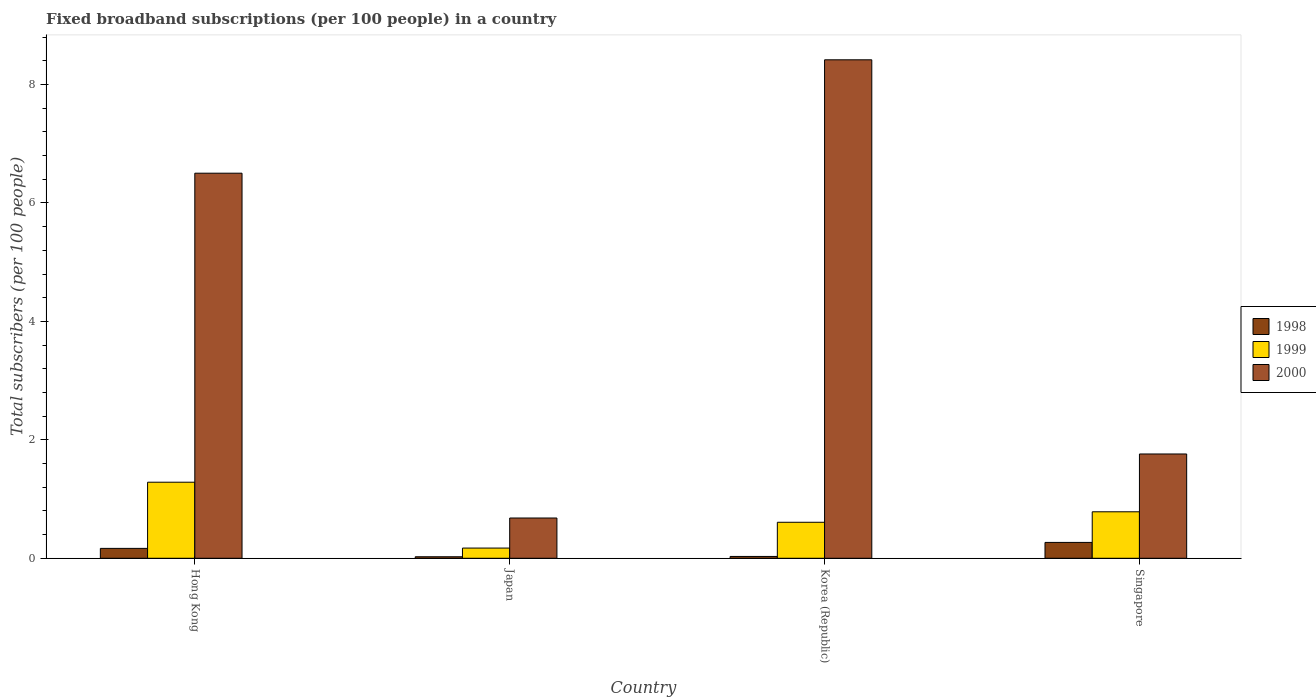How many different coloured bars are there?
Make the answer very short. 3. Are the number of bars on each tick of the X-axis equal?
Your answer should be very brief. Yes. How many bars are there on the 3rd tick from the left?
Your answer should be compact. 3. How many bars are there on the 2nd tick from the right?
Make the answer very short. 3. What is the label of the 4th group of bars from the left?
Ensure brevity in your answer.  Singapore. What is the number of broadband subscriptions in 2000 in Hong Kong?
Your response must be concise. 6.5. Across all countries, what is the maximum number of broadband subscriptions in 1998?
Make the answer very short. 0.27. Across all countries, what is the minimum number of broadband subscriptions in 2000?
Keep it short and to the point. 0.68. In which country was the number of broadband subscriptions in 1999 maximum?
Make the answer very short. Hong Kong. What is the total number of broadband subscriptions in 1998 in the graph?
Provide a succinct answer. 0.49. What is the difference between the number of broadband subscriptions in 1998 in Hong Kong and that in Singapore?
Keep it short and to the point. -0.1. What is the difference between the number of broadband subscriptions in 1999 in Korea (Republic) and the number of broadband subscriptions in 2000 in Japan?
Offer a very short reply. -0.07. What is the average number of broadband subscriptions in 1998 per country?
Your answer should be compact. 0.12. What is the difference between the number of broadband subscriptions of/in 2000 and number of broadband subscriptions of/in 1999 in Hong Kong?
Make the answer very short. 5.22. In how many countries, is the number of broadband subscriptions in 1999 greater than 3.2?
Your response must be concise. 0. What is the ratio of the number of broadband subscriptions in 1998 in Hong Kong to that in Singapore?
Offer a very short reply. 0.62. What is the difference between the highest and the second highest number of broadband subscriptions in 2000?
Give a very brief answer. 6.66. What is the difference between the highest and the lowest number of broadband subscriptions in 1999?
Provide a short and direct response. 1.11. In how many countries, is the number of broadband subscriptions in 1998 greater than the average number of broadband subscriptions in 1998 taken over all countries?
Offer a very short reply. 2. Is the sum of the number of broadband subscriptions in 1998 in Hong Kong and Singapore greater than the maximum number of broadband subscriptions in 2000 across all countries?
Your response must be concise. No. What does the 1st bar from the right in Korea (Republic) represents?
Provide a short and direct response. 2000. Is it the case that in every country, the sum of the number of broadband subscriptions in 2000 and number of broadband subscriptions in 1999 is greater than the number of broadband subscriptions in 1998?
Give a very brief answer. Yes. How many bars are there?
Keep it short and to the point. 12. How many legend labels are there?
Offer a terse response. 3. How are the legend labels stacked?
Ensure brevity in your answer.  Vertical. What is the title of the graph?
Your answer should be compact. Fixed broadband subscriptions (per 100 people) in a country. Does "1990" appear as one of the legend labels in the graph?
Offer a very short reply. No. What is the label or title of the X-axis?
Your response must be concise. Country. What is the label or title of the Y-axis?
Your response must be concise. Total subscribers (per 100 people). What is the Total subscribers (per 100 people) of 1998 in Hong Kong?
Provide a short and direct response. 0.17. What is the Total subscribers (per 100 people) in 1999 in Hong Kong?
Your response must be concise. 1.28. What is the Total subscribers (per 100 people) in 2000 in Hong Kong?
Ensure brevity in your answer.  6.5. What is the Total subscribers (per 100 people) in 1998 in Japan?
Your answer should be very brief. 0.03. What is the Total subscribers (per 100 people) of 1999 in Japan?
Provide a short and direct response. 0.17. What is the Total subscribers (per 100 people) in 2000 in Japan?
Provide a succinct answer. 0.68. What is the Total subscribers (per 100 people) in 1998 in Korea (Republic)?
Keep it short and to the point. 0.03. What is the Total subscribers (per 100 people) of 1999 in Korea (Republic)?
Provide a short and direct response. 0.61. What is the Total subscribers (per 100 people) of 2000 in Korea (Republic)?
Offer a terse response. 8.42. What is the Total subscribers (per 100 people) in 1998 in Singapore?
Ensure brevity in your answer.  0.27. What is the Total subscribers (per 100 people) of 1999 in Singapore?
Provide a succinct answer. 0.78. What is the Total subscribers (per 100 people) of 2000 in Singapore?
Your answer should be compact. 1.76. Across all countries, what is the maximum Total subscribers (per 100 people) of 1998?
Make the answer very short. 0.27. Across all countries, what is the maximum Total subscribers (per 100 people) in 1999?
Keep it short and to the point. 1.28. Across all countries, what is the maximum Total subscribers (per 100 people) of 2000?
Ensure brevity in your answer.  8.42. Across all countries, what is the minimum Total subscribers (per 100 people) in 1998?
Give a very brief answer. 0.03. Across all countries, what is the minimum Total subscribers (per 100 people) in 1999?
Offer a terse response. 0.17. Across all countries, what is the minimum Total subscribers (per 100 people) in 2000?
Your response must be concise. 0.68. What is the total Total subscribers (per 100 people) of 1998 in the graph?
Offer a terse response. 0.49. What is the total Total subscribers (per 100 people) of 1999 in the graph?
Keep it short and to the point. 2.85. What is the total Total subscribers (per 100 people) in 2000 in the graph?
Offer a terse response. 17.36. What is the difference between the Total subscribers (per 100 people) of 1998 in Hong Kong and that in Japan?
Give a very brief answer. 0.14. What is the difference between the Total subscribers (per 100 people) in 1999 in Hong Kong and that in Japan?
Keep it short and to the point. 1.11. What is the difference between the Total subscribers (per 100 people) in 2000 in Hong Kong and that in Japan?
Provide a short and direct response. 5.82. What is the difference between the Total subscribers (per 100 people) of 1998 in Hong Kong and that in Korea (Republic)?
Your answer should be very brief. 0.14. What is the difference between the Total subscribers (per 100 people) in 1999 in Hong Kong and that in Korea (Republic)?
Offer a terse response. 0.68. What is the difference between the Total subscribers (per 100 people) of 2000 in Hong Kong and that in Korea (Republic)?
Provide a short and direct response. -1.91. What is the difference between the Total subscribers (per 100 people) in 1998 in Hong Kong and that in Singapore?
Your answer should be very brief. -0.1. What is the difference between the Total subscribers (per 100 people) in 1999 in Hong Kong and that in Singapore?
Offer a terse response. 0.5. What is the difference between the Total subscribers (per 100 people) in 2000 in Hong Kong and that in Singapore?
Ensure brevity in your answer.  4.74. What is the difference between the Total subscribers (per 100 people) of 1998 in Japan and that in Korea (Republic)?
Your answer should be compact. -0.01. What is the difference between the Total subscribers (per 100 people) in 1999 in Japan and that in Korea (Republic)?
Offer a very short reply. -0.44. What is the difference between the Total subscribers (per 100 people) in 2000 in Japan and that in Korea (Republic)?
Provide a short and direct response. -7.74. What is the difference between the Total subscribers (per 100 people) of 1998 in Japan and that in Singapore?
Provide a short and direct response. -0.24. What is the difference between the Total subscribers (per 100 people) in 1999 in Japan and that in Singapore?
Provide a succinct answer. -0.61. What is the difference between the Total subscribers (per 100 people) in 2000 in Japan and that in Singapore?
Provide a short and direct response. -1.08. What is the difference between the Total subscribers (per 100 people) in 1998 in Korea (Republic) and that in Singapore?
Your response must be concise. -0.24. What is the difference between the Total subscribers (per 100 people) of 1999 in Korea (Republic) and that in Singapore?
Offer a terse response. -0.18. What is the difference between the Total subscribers (per 100 people) of 2000 in Korea (Republic) and that in Singapore?
Offer a very short reply. 6.66. What is the difference between the Total subscribers (per 100 people) in 1998 in Hong Kong and the Total subscribers (per 100 people) in 1999 in Japan?
Ensure brevity in your answer.  -0.01. What is the difference between the Total subscribers (per 100 people) in 1998 in Hong Kong and the Total subscribers (per 100 people) in 2000 in Japan?
Your response must be concise. -0.51. What is the difference between the Total subscribers (per 100 people) in 1999 in Hong Kong and the Total subscribers (per 100 people) in 2000 in Japan?
Make the answer very short. 0.6. What is the difference between the Total subscribers (per 100 people) of 1998 in Hong Kong and the Total subscribers (per 100 people) of 1999 in Korea (Republic)?
Provide a short and direct response. -0.44. What is the difference between the Total subscribers (per 100 people) of 1998 in Hong Kong and the Total subscribers (per 100 people) of 2000 in Korea (Republic)?
Provide a short and direct response. -8.25. What is the difference between the Total subscribers (per 100 people) in 1999 in Hong Kong and the Total subscribers (per 100 people) in 2000 in Korea (Republic)?
Your answer should be compact. -7.13. What is the difference between the Total subscribers (per 100 people) of 1998 in Hong Kong and the Total subscribers (per 100 people) of 1999 in Singapore?
Offer a very short reply. -0.62. What is the difference between the Total subscribers (per 100 people) in 1998 in Hong Kong and the Total subscribers (per 100 people) in 2000 in Singapore?
Make the answer very short. -1.59. What is the difference between the Total subscribers (per 100 people) of 1999 in Hong Kong and the Total subscribers (per 100 people) of 2000 in Singapore?
Keep it short and to the point. -0.48. What is the difference between the Total subscribers (per 100 people) in 1998 in Japan and the Total subscribers (per 100 people) in 1999 in Korea (Republic)?
Keep it short and to the point. -0.58. What is the difference between the Total subscribers (per 100 people) of 1998 in Japan and the Total subscribers (per 100 people) of 2000 in Korea (Republic)?
Offer a very short reply. -8.39. What is the difference between the Total subscribers (per 100 people) of 1999 in Japan and the Total subscribers (per 100 people) of 2000 in Korea (Republic)?
Your answer should be very brief. -8.25. What is the difference between the Total subscribers (per 100 people) of 1998 in Japan and the Total subscribers (per 100 people) of 1999 in Singapore?
Offer a terse response. -0.76. What is the difference between the Total subscribers (per 100 people) in 1998 in Japan and the Total subscribers (per 100 people) in 2000 in Singapore?
Your response must be concise. -1.74. What is the difference between the Total subscribers (per 100 people) in 1999 in Japan and the Total subscribers (per 100 people) in 2000 in Singapore?
Your answer should be compact. -1.59. What is the difference between the Total subscribers (per 100 people) of 1998 in Korea (Republic) and the Total subscribers (per 100 people) of 1999 in Singapore?
Keep it short and to the point. -0.75. What is the difference between the Total subscribers (per 100 people) of 1998 in Korea (Republic) and the Total subscribers (per 100 people) of 2000 in Singapore?
Provide a succinct answer. -1.73. What is the difference between the Total subscribers (per 100 people) in 1999 in Korea (Republic) and the Total subscribers (per 100 people) in 2000 in Singapore?
Keep it short and to the point. -1.15. What is the average Total subscribers (per 100 people) in 1998 per country?
Your answer should be very brief. 0.12. What is the average Total subscribers (per 100 people) of 1999 per country?
Ensure brevity in your answer.  0.71. What is the average Total subscribers (per 100 people) of 2000 per country?
Offer a terse response. 4.34. What is the difference between the Total subscribers (per 100 people) of 1998 and Total subscribers (per 100 people) of 1999 in Hong Kong?
Your answer should be very brief. -1.12. What is the difference between the Total subscribers (per 100 people) in 1998 and Total subscribers (per 100 people) in 2000 in Hong Kong?
Ensure brevity in your answer.  -6.34. What is the difference between the Total subscribers (per 100 people) in 1999 and Total subscribers (per 100 people) in 2000 in Hong Kong?
Provide a succinct answer. -5.22. What is the difference between the Total subscribers (per 100 people) of 1998 and Total subscribers (per 100 people) of 1999 in Japan?
Make the answer very short. -0.15. What is the difference between the Total subscribers (per 100 people) of 1998 and Total subscribers (per 100 people) of 2000 in Japan?
Ensure brevity in your answer.  -0.65. What is the difference between the Total subscribers (per 100 people) of 1999 and Total subscribers (per 100 people) of 2000 in Japan?
Provide a short and direct response. -0.51. What is the difference between the Total subscribers (per 100 people) of 1998 and Total subscribers (per 100 people) of 1999 in Korea (Republic)?
Your answer should be very brief. -0.58. What is the difference between the Total subscribers (per 100 people) in 1998 and Total subscribers (per 100 people) in 2000 in Korea (Republic)?
Ensure brevity in your answer.  -8.39. What is the difference between the Total subscribers (per 100 people) in 1999 and Total subscribers (per 100 people) in 2000 in Korea (Republic)?
Keep it short and to the point. -7.81. What is the difference between the Total subscribers (per 100 people) of 1998 and Total subscribers (per 100 people) of 1999 in Singapore?
Give a very brief answer. -0.52. What is the difference between the Total subscribers (per 100 people) in 1998 and Total subscribers (per 100 people) in 2000 in Singapore?
Offer a terse response. -1.49. What is the difference between the Total subscribers (per 100 people) of 1999 and Total subscribers (per 100 people) of 2000 in Singapore?
Provide a short and direct response. -0.98. What is the ratio of the Total subscribers (per 100 people) in 1998 in Hong Kong to that in Japan?
Offer a very short reply. 6.53. What is the ratio of the Total subscribers (per 100 people) of 1999 in Hong Kong to that in Japan?
Give a very brief answer. 7.46. What is the ratio of the Total subscribers (per 100 people) of 2000 in Hong Kong to that in Japan?
Your answer should be compact. 9.56. What is the ratio of the Total subscribers (per 100 people) of 1998 in Hong Kong to that in Korea (Republic)?
Provide a succinct answer. 5.42. What is the ratio of the Total subscribers (per 100 people) in 1999 in Hong Kong to that in Korea (Republic)?
Keep it short and to the point. 2.11. What is the ratio of the Total subscribers (per 100 people) in 2000 in Hong Kong to that in Korea (Republic)?
Offer a very short reply. 0.77. What is the ratio of the Total subscribers (per 100 people) in 1998 in Hong Kong to that in Singapore?
Offer a very short reply. 0.62. What is the ratio of the Total subscribers (per 100 people) in 1999 in Hong Kong to that in Singapore?
Provide a short and direct response. 1.64. What is the ratio of the Total subscribers (per 100 people) in 2000 in Hong Kong to that in Singapore?
Your response must be concise. 3.69. What is the ratio of the Total subscribers (per 100 people) of 1998 in Japan to that in Korea (Republic)?
Your response must be concise. 0.83. What is the ratio of the Total subscribers (per 100 people) in 1999 in Japan to that in Korea (Republic)?
Give a very brief answer. 0.28. What is the ratio of the Total subscribers (per 100 people) in 2000 in Japan to that in Korea (Republic)?
Give a very brief answer. 0.08. What is the ratio of the Total subscribers (per 100 people) of 1998 in Japan to that in Singapore?
Give a very brief answer. 0.1. What is the ratio of the Total subscribers (per 100 people) of 1999 in Japan to that in Singapore?
Offer a terse response. 0.22. What is the ratio of the Total subscribers (per 100 people) in 2000 in Japan to that in Singapore?
Keep it short and to the point. 0.39. What is the ratio of the Total subscribers (per 100 people) of 1998 in Korea (Republic) to that in Singapore?
Your answer should be compact. 0.12. What is the ratio of the Total subscribers (per 100 people) in 1999 in Korea (Republic) to that in Singapore?
Keep it short and to the point. 0.77. What is the ratio of the Total subscribers (per 100 people) in 2000 in Korea (Republic) to that in Singapore?
Keep it short and to the point. 4.78. What is the difference between the highest and the second highest Total subscribers (per 100 people) in 1998?
Offer a terse response. 0.1. What is the difference between the highest and the second highest Total subscribers (per 100 people) of 1999?
Keep it short and to the point. 0.5. What is the difference between the highest and the second highest Total subscribers (per 100 people) of 2000?
Ensure brevity in your answer.  1.91. What is the difference between the highest and the lowest Total subscribers (per 100 people) of 1998?
Your answer should be compact. 0.24. What is the difference between the highest and the lowest Total subscribers (per 100 people) in 1999?
Provide a short and direct response. 1.11. What is the difference between the highest and the lowest Total subscribers (per 100 people) in 2000?
Your response must be concise. 7.74. 